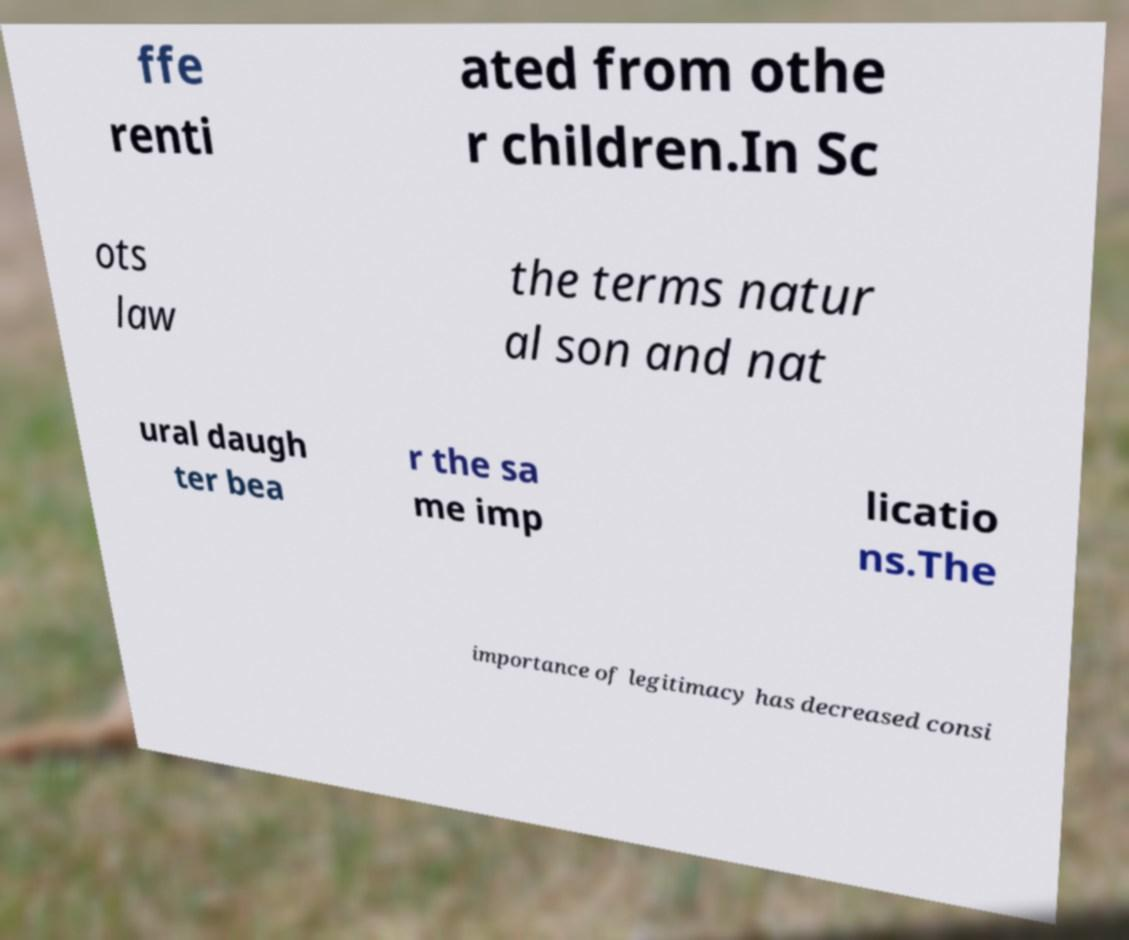There's text embedded in this image that I need extracted. Can you transcribe it verbatim? ffe renti ated from othe r children.In Sc ots law the terms natur al son and nat ural daugh ter bea r the sa me imp licatio ns.The importance of legitimacy has decreased consi 